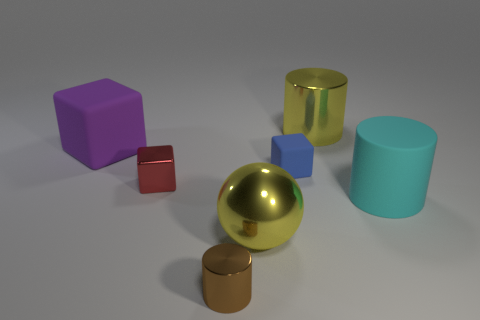What number of spheres are either tiny cyan rubber things or big purple rubber objects?
Your response must be concise. 0. Are there the same number of small shiny cubes in front of the big cyan matte object and large cyan rubber objects behind the small rubber block?
Your response must be concise. Yes. How many large cylinders are in front of the big yellow shiny object in front of the tiny block that is to the left of the small brown object?
Keep it short and to the point. 0. There is a big metal thing that is the same color as the large shiny cylinder; what is its shape?
Your answer should be very brief. Sphere. Do the big ball and the shiny cylinder behind the blue block have the same color?
Offer a very short reply. Yes. Is the number of cylinders behind the red metallic thing greater than the number of small green rubber cylinders?
Offer a very short reply. Yes. How many things are rubber things that are on the right side of the purple matte block or large things that are behind the big cyan rubber cylinder?
Give a very brief answer. 4. What size is the other cube that is made of the same material as the purple cube?
Offer a very short reply. Small. Is the shape of the large rubber object that is behind the small blue object the same as  the red metal object?
Make the answer very short. Yes. What number of blue things are either large metallic cylinders or rubber blocks?
Give a very brief answer. 1. 